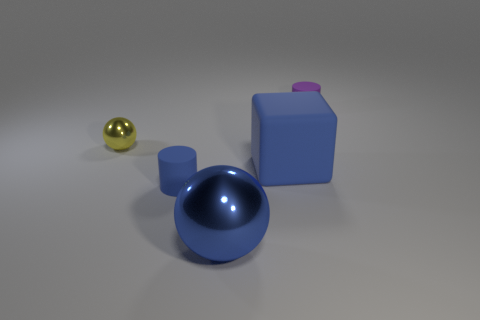There is another yellow metallic object that is the same shape as the large metallic thing; what is its size?
Keep it short and to the point. Small. What number of things have the same material as the large blue block?
Give a very brief answer. 2. Is the small thing that is on the right side of the big metallic thing made of the same material as the small yellow thing?
Offer a terse response. No. Are there an equal number of big shiny objects that are behind the tiny shiny thing and blue metal objects?
Your response must be concise. No. The blue shiny object has what size?
Your answer should be compact. Large. There is a tiny cylinder that is the same color as the big metal thing; what is its material?
Make the answer very short. Rubber. What number of tiny metallic spheres have the same color as the cube?
Make the answer very short. 0. Is the size of the yellow metallic thing the same as the purple cylinder?
Give a very brief answer. Yes. What size is the blue object on the right side of the ball that is in front of the tiny blue thing?
Offer a very short reply. Large. There is a small ball; does it have the same color as the tiny matte cylinder left of the big metal object?
Offer a very short reply. No. 